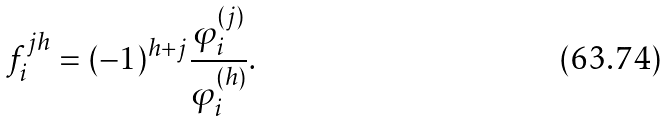Convert formula to latex. <formula><loc_0><loc_0><loc_500><loc_500>f _ { i } ^ { j h } = ( - 1 ) ^ { h + j } \frac { \varphi _ { i } ^ { ( j ) } } { \varphi _ { i } ^ { ( h ) } } .</formula> 